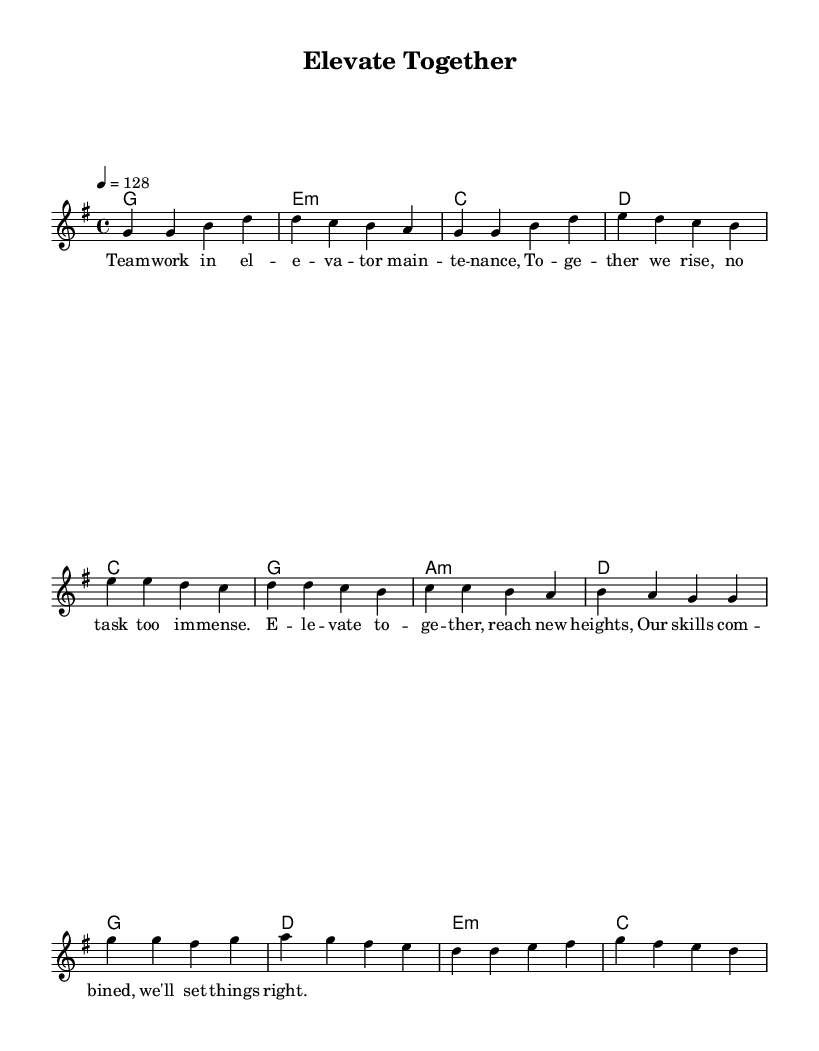What is the key signature of this music? The key signature is G major, which has one sharp (F#). This can be identified in the music sheet where the G major key is shown at the beginning.
Answer: G major What is the time signature of this music? The time signature appears as 4/4 at the start of the music sheet, indicating that there are four beats per measure, with a quarter note receiving one beat.
Answer: 4/4 What is the tempo marking of this composition? The tempo marking is indicated as 4 = 128, which shows that there are 128 beats per minute. This is specified right after the time signature in the music sheet.
Answer: 128 How many verses are included in the song? The song contains one verse as indicated by the structure outlined in the melody section. The lyrics and their alignment correspond with the melodic line provided for that section.
Answer: One verse What chords are used in the pre-chorus? The chords used in the pre-chorus are C, G, A minor, and D. These can be found in the harmonies section, where the chord progression for the pre-chorus is specified directly below the melody.
Answer: C, G, A minor, D What thematic element is emphasized in the lyrics of the song? The lyrics emphasize teamwork and collaboration, illustrated in phrases that mention working together and combining skills to reach new heights. The context of the lyrics supports this professional theme.
Answer: Teamwork and collaboration How many musical sections are identified in this piece? There are three distinct sections identified: Verse, Pre-Chorus, and Chorus. This structure is commonly used in K-Pop and is represented in the layout of the music sheet where these sections are clearly labeled.
Answer: Three sections 